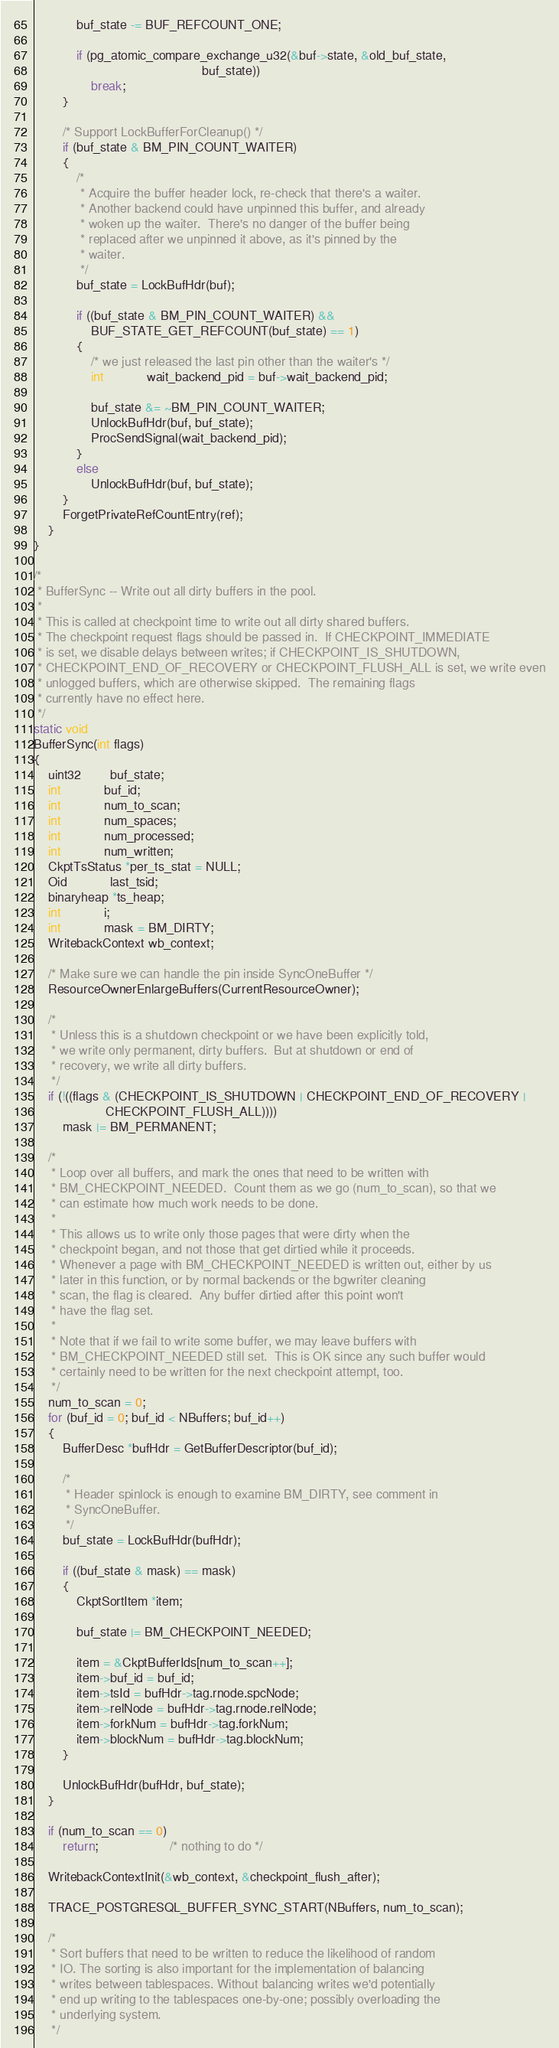Convert code to text. <code><loc_0><loc_0><loc_500><loc_500><_C_>			buf_state -= BUF_REFCOUNT_ONE;

			if (pg_atomic_compare_exchange_u32(&buf->state, &old_buf_state,
											   buf_state))
				break;
		}

		/* Support LockBufferForCleanup() */
		if (buf_state & BM_PIN_COUNT_WAITER)
		{
			/*
			 * Acquire the buffer header lock, re-check that there's a waiter.
			 * Another backend could have unpinned this buffer, and already
			 * woken up the waiter.  There's no danger of the buffer being
			 * replaced after we unpinned it above, as it's pinned by the
			 * waiter.
			 */
			buf_state = LockBufHdr(buf);

			if ((buf_state & BM_PIN_COUNT_WAITER) &&
				BUF_STATE_GET_REFCOUNT(buf_state) == 1)
			{
				/* we just released the last pin other than the waiter's */
				int			wait_backend_pid = buf->wait_backend_pid;

				buf_state &= ~BM_PIN_COUNT_WAITER;
				UnlockBufHdr(buf, buf_state);
				ProcSendSignal(wait_backend_pid);
			}
			else
				UnlockBufHdr(buf, buf_state);
		}
		ForgetPrivateRefCountEntry(ref);
	}
}

/*
 * BufferSync -- Write out all dirty buffers in the pool.
 *
 * This is called at checkpoint time to write out all dirty shared buffers.
 * The checkpoint request flags should be passed in.  If CHECKPOINT_IMMEDIATE
 * is set, we disable delays between writes; if CHECKPOINT_IS_SHUTDOWN,
 * CHECKPOINT_END_OF_RECOVERY or CHECKPOINT_FLUSH_ALL is set, we write even
 * unlogged buffers, which are otherwise skipped.  The remaining flags
 * currently have no effect here.
 */
static void
BufferSync(int flags)
{
	uint32		buf_state;
	int			buf_id;
	int			num_to_scan;
	int			num_spaces;
	int			num_processed;
	int			num_written;
	CkptTsStatus *per_ts_stat = NULL;
	Oid			last_tsid;
	binaryheap *ts_heap;
	int			i;
	int			mask = BM_DIRTY;
	WritebackContext wb_context;

	/* Make sure we can handle the pin inside SyncOneBuffer */
	ResourceOwnerEnlargeBuffers(CurrentResourceOwner);

	/*
	 * Unless this is a shutdown checkpoint or we have been explicitly told,
	 * we write only permanent, dirty buffers.  But at shutdown or end of
	 * recovery, we write all dirty buffers.
	 */
	if (!((flags & (CHECKPOINT_IS_SHUTDOWN | CHECKPOINT_END_OF_RECOVERY |
					CHECKPOINT_FLUSH_ALL))))
		mask |= BM_PERMANENT;

	/*
	 * Loop over all buffers, and mark the ones that need to be written with
	 * BM_CHECKPOINT_NEEDED.  Count them as we go (num_to_scan), so that we
	 * can estimate how much work needs to be done.
	 *
	 * This allows us to write only those pages that were dirty when the
	 * checkpoint began, and not those that get dirtied while it proceeds.
	 * Whenever a page with BM_CHECKPOINT_NEEDED is written out, either by us
	 * later in this function, or by normal backends or the bgwriter cleaning
	 * scan, the flag is cleared.  Any buffer dirtied after this point won't
	 * have the flag set.
	 *
	 * Note that if we fail to write some buffer, we may leave buffers with
	 * BM_CHECKPOINT_NEEDED still set.  This is OK since any such buffer would
	 * certainly need to be written for the next checkpoint attempt, too.
	 */
	num_to_scan = 0;
	for (buf_id = 0; buf_id < NBuffers; buf_id++)
	{
		BufferDesc *bufHdr = GetBufferDescriptor(buf_id);

		/*
		 * Header spinlock is enough to examine BM_DIRTY, see comment in
		 * SyncOneBuffer.
		 */
		buf_state = LockBufHdr(bufHdr);

		if ((buf_state & mask) == mask)
		{
			CkptSortItem *item;

			buf_state |= BM_CHECKPOINT_NEEDED;

			item = &CkptBufferIds[num_to_scan++];
			item->buf_id = buf_id;
			item->tsId = bufHdr->tag.rnode.spcNode;
			item->relNode = bufHdr->tag.rnode.relNode;
			item->forkNum = bufHdr->tag.forkNum;
			item->blockNum = bufHdr->tag.blockNum;
		}

		UnlockBufHdr(bufHdr, buf_state);
	}

	if (num_to_scan == 0)
		return;					/* nothing to do */

	WritebackContextInit(&wb_context, &checkpoint_flush_after);

	TRACE_POSTGRESQL_BUFFER_SYNC_START(NBuffers, num_to_scan);

	/*
	 * Sort buffers that need to be written to reduce the likelihood of random
	 * IO. The sorting is also important for the implementation of balancing
	 * writes between tablespaces. Without balancing writes we'd potentially
	 * end up writing to the tablespaces one-by-one; possibly overloading the
	 * underlying system.
	 */</code> 